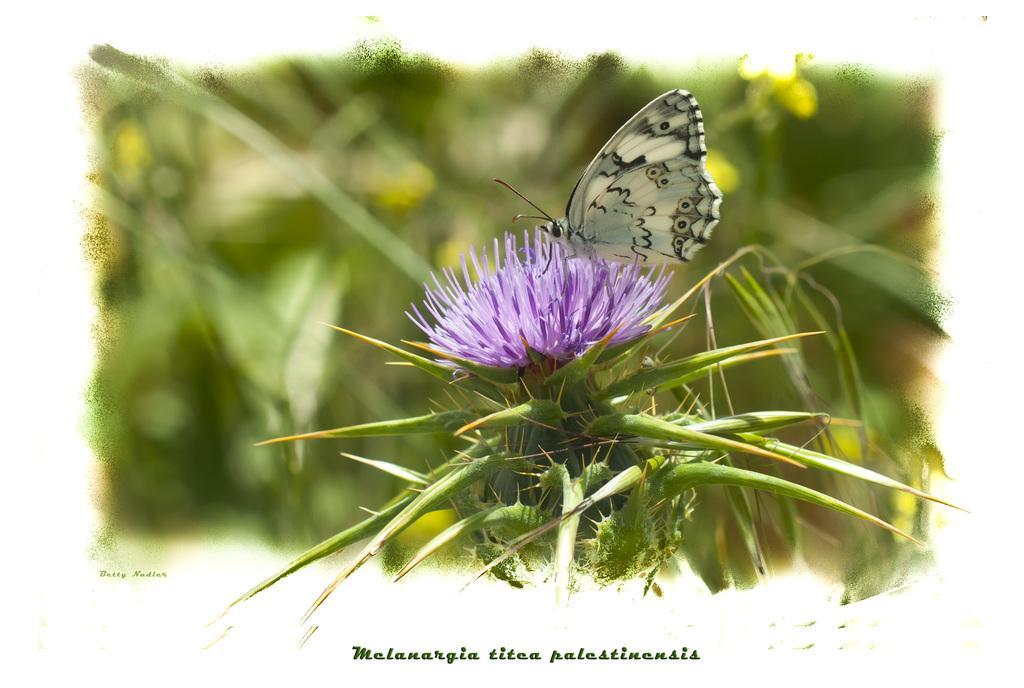Please provide a concise description of this image. In this image I can see a plant , on the plant I can see a flower and on the flower I can see a butterfly ,at the bottom I can see text and background is blurry. 